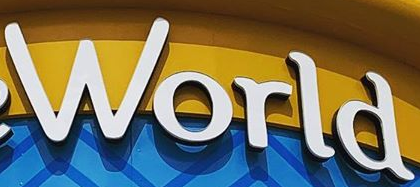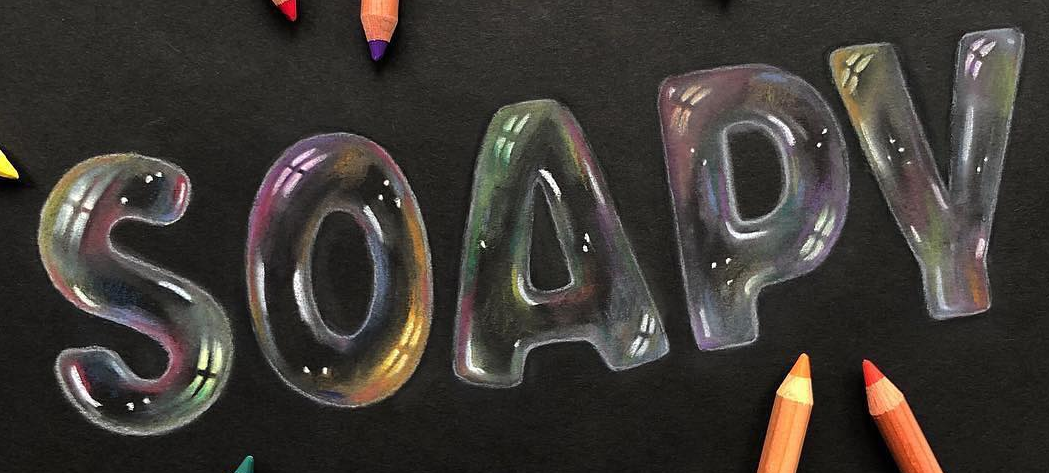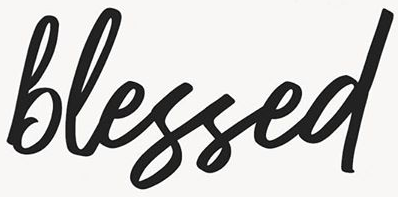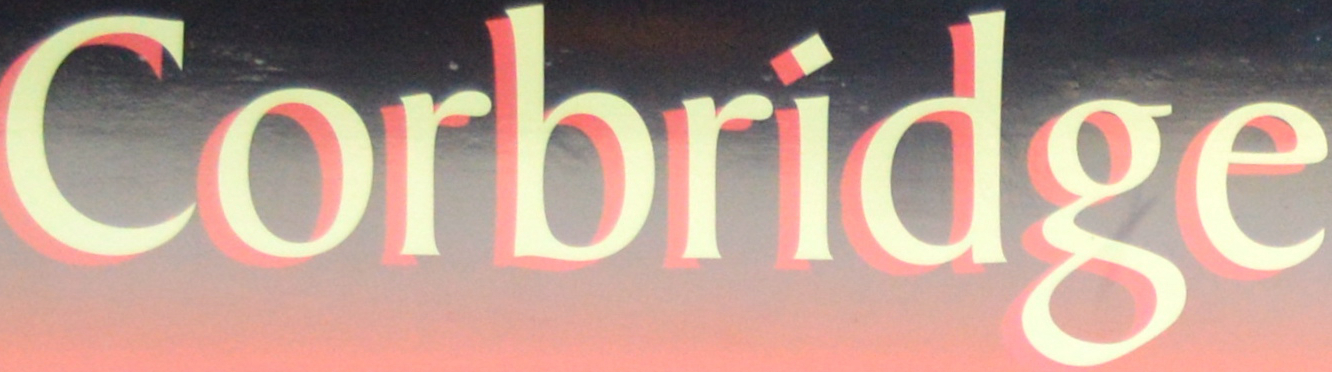What text is displayed in these images sequentially, separated by a semicolon? World; SOAPY; blessed; Corbridge 